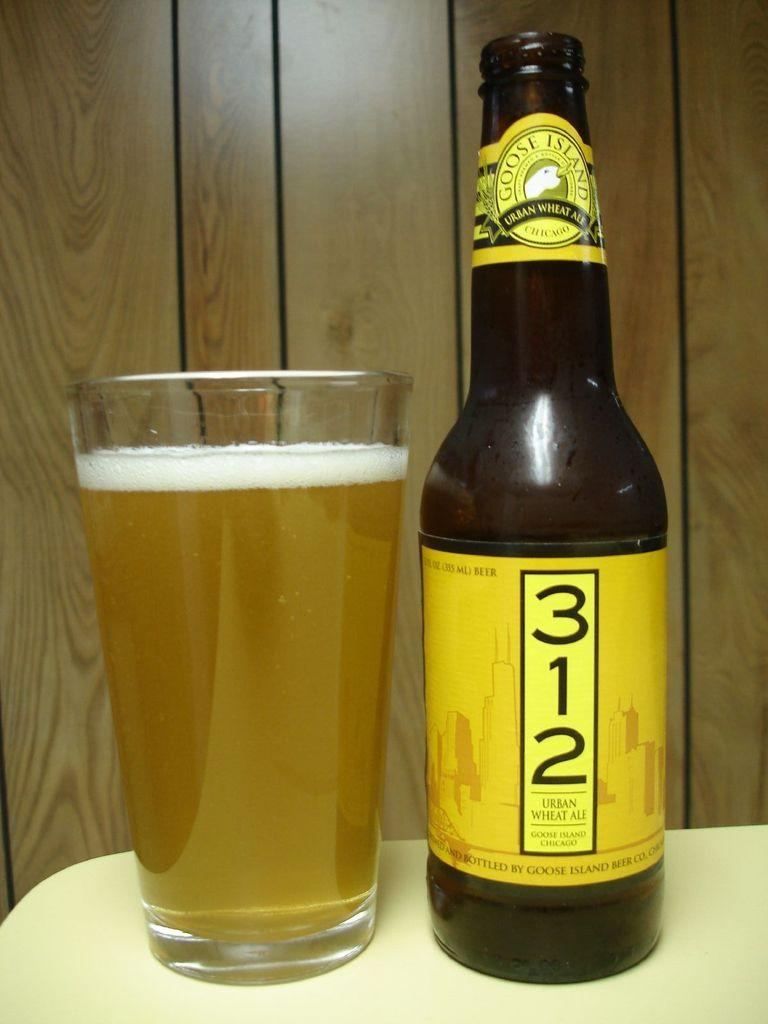Provide a one-sentence caption for the provided image. A bottle of 312 beer sitting next to a pint glass filled with beer. 